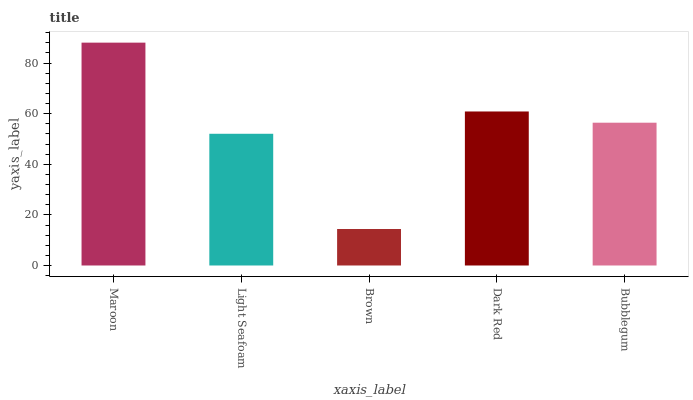Is Brown the minimum?
Answer yes or no. Yes. Is Maroon the maximum?
Answer yes or no. Yes. Is Light Seafoam the minimum?
Answer yes or no. No. Is Light Seafoam the maximum?
Answer yes or no. No. Is Maroon greater than Light Seafoam?
Answer yes or no. Yes. Is Light Seafoam less than Maroon?
Answer yes or no. Yes. Is Light Seafoam greater than Maroon?
Answer yes or no. No. Is Maroon less than Light Seafoam?
Answer yes or no. No. Is Bubblegum the high median?
Answer yes or no. Yes. Is Bubblegum the low median?
Answer yes or no. Yes. Is Brown the high median?
Answer yes or no. No. Is Light Seafoam the low median?
Answer yes or no. No. 